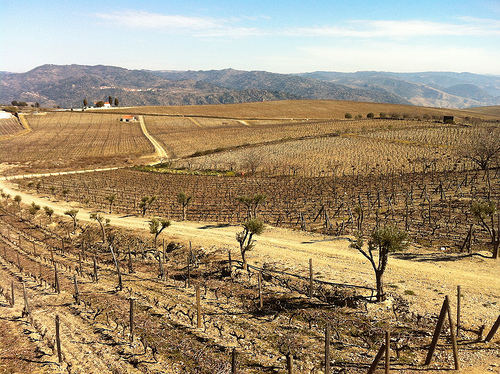<image>
Is there a mountain in the sky? No. The mountain is not contained within the sky. These objects have a different spatial relationship. Where is the road in relation to the road? Is it above the road? No. The road is not positioned above the road. The vertical arrangement shows a different relationship. 